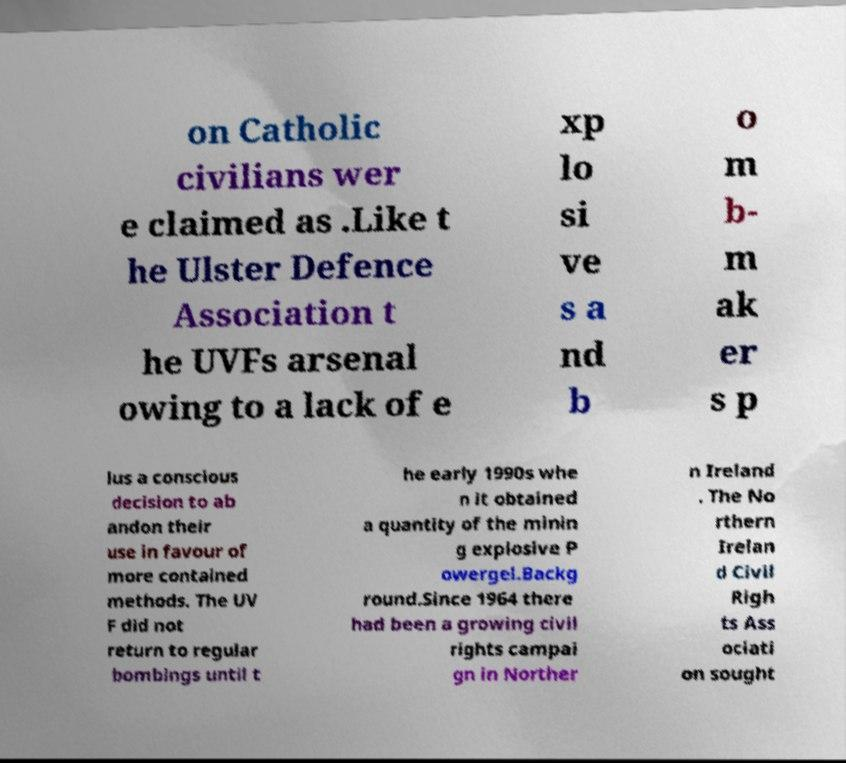Can you read and provide the text displayed in the image?This photo seems to have some interesting text. Can you extract and type it out for me? on Catholic civilians wer e claimed as .Like t he Ulster Defence Association t he UVFs arsenal owing to a lack of e xp lo si ve s a nd b o m b- m ak er s p lus a conscious decision to ab andon their use in favour of more contained methods. The UV F did not return to regular bombings until t he early 1990s whe n it obtained a quantity of the minin g explosive P owergel.Backg round.Since 1964 there had been a growing civil rights campai gn in Norther n Ireland . The No rthern Irelan d Civil Righ ts Ass ociati on sought 